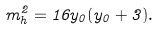Convert formula to latex. <formula><loc_0><loc_0><loc_500><loc_500>m _ { h } ^ { 2 } = 1 6 y _ { 0 } ( y _ { 0 } + 3 ) .</formula> 